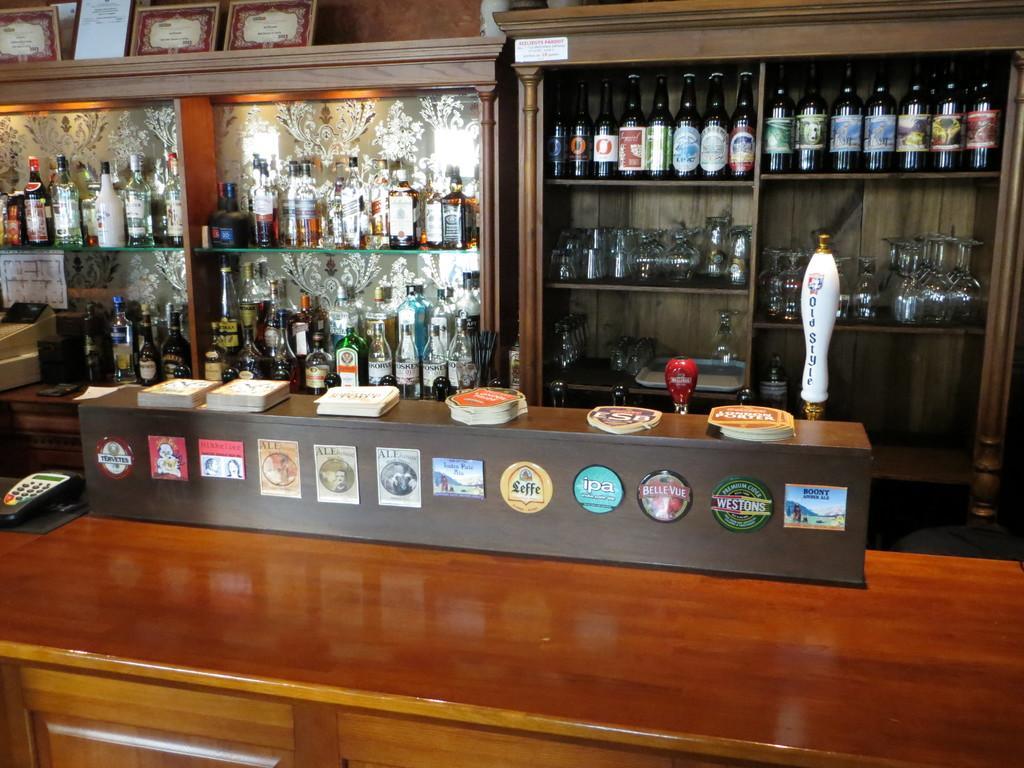Describe this image in one or two sentences. In this image there are few shelves having bottles in it. Front side of image there is a table having a device and an object having few papers on it. Top of image there are few frames. 